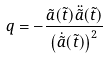Convert formula to latex. <formula><loc_0><loc_0><loc_500><loc_500>q = - \frac { \tilde { a } ( \tilde { t } ) \ddot { \tilde { a } } ( \tilde { t } ) } { \left ( \dot { \tilde { a } } ( \tilde { t } ) \right ) ^ { 2 } }</formula> 